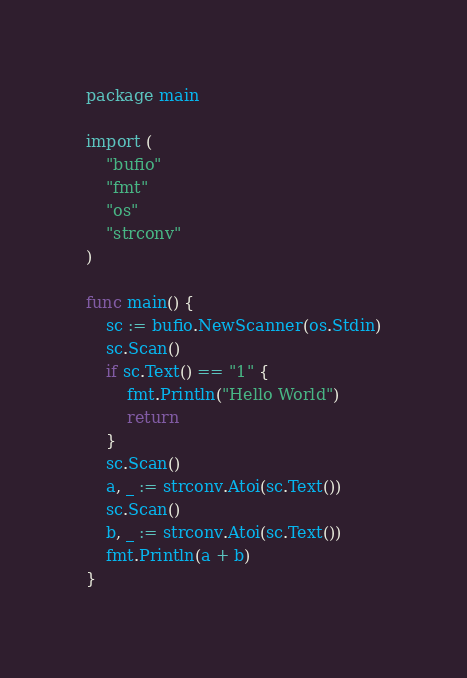Convert code to text. <code><loc_0><loc_0><loc_500><loc_500><_Go_>package main

import (
	"bufio"
	"fmt"
	"os"
	"strconv"
)

func main() {
	sc := bufio.NewScanner(os.Stdin)
	sc.Scan()
	if sc.Text() == "1" {
		fmt.Println("Hello World")
		return
	}
	sc.Scan()
	a, _ := strconv.Atoi(sc.Text())
	sc.Scan()
	b, _ := strconv.Atoi(sc.Text())
	fmt.Println(a + b)
}
</code> 